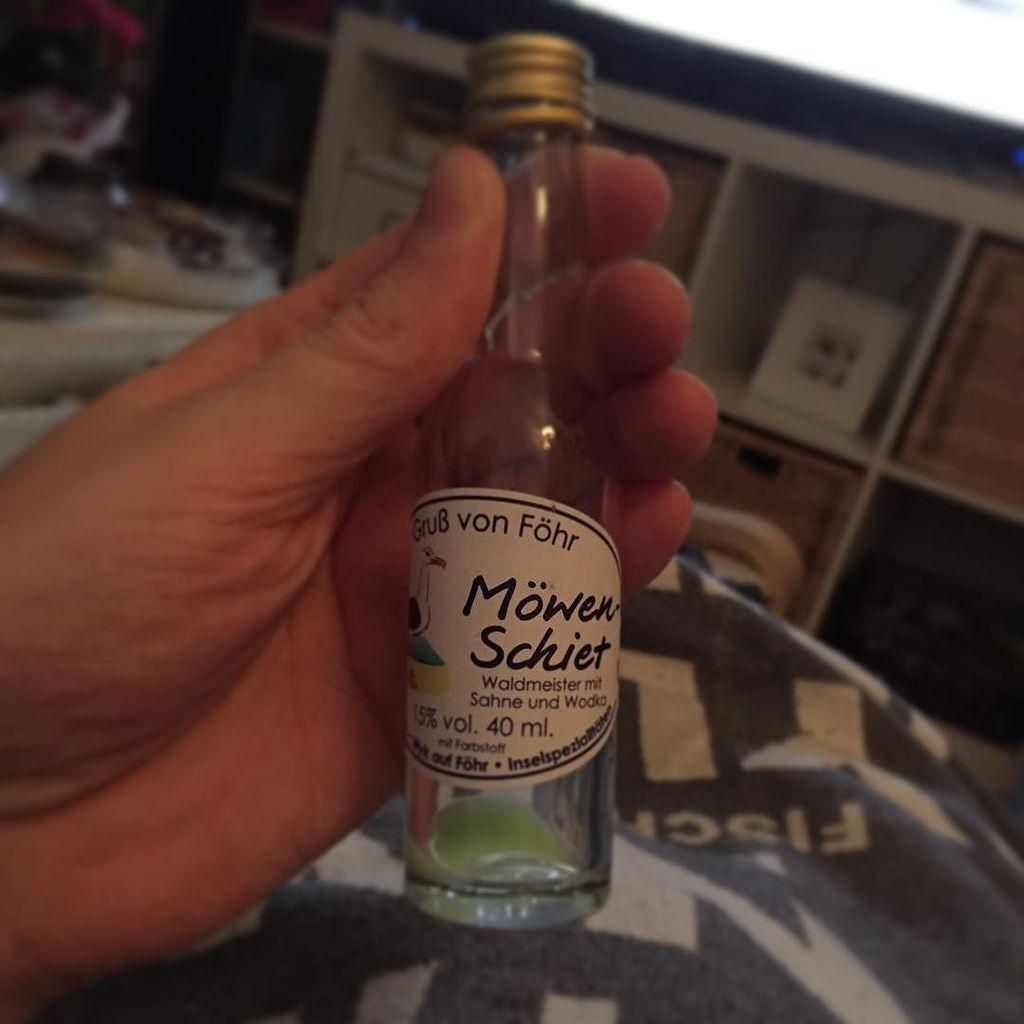<image>
Offer a succinct explanation of the picture presented. A hand is holding a small bottle of Waldmeister mit Sahne und Wodka. 